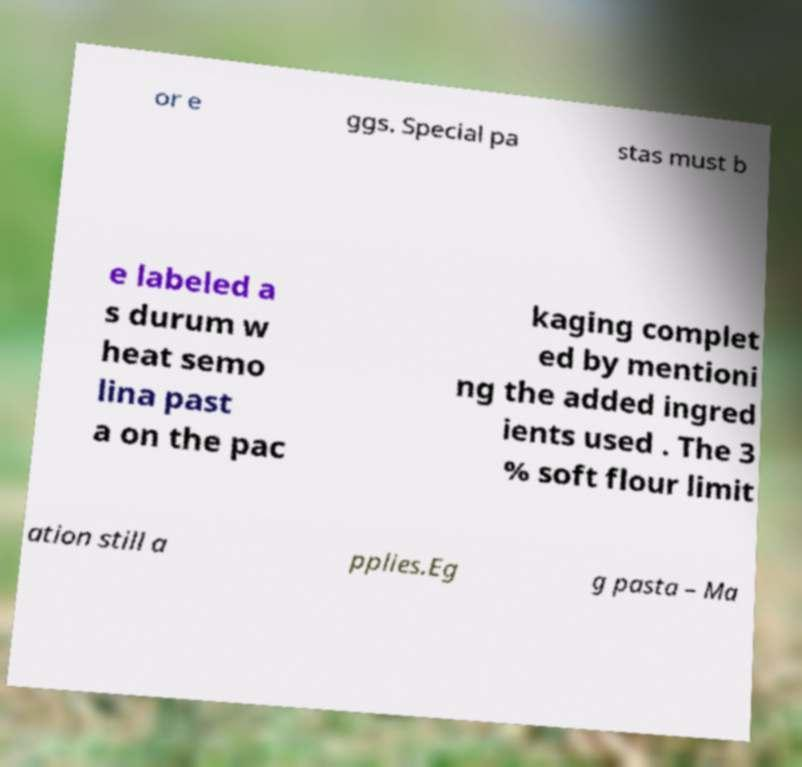Could you assist in decoding the text presented in this image and type it out clearly? or e ggs. Special pa stas must b e labeled a s durum w heat semo lina past a on the pac kaging complet ed by mentioni ng the added ingred ients used . The 3 % soft flour limit ation still a pplies.Eg g pasta – Ma 